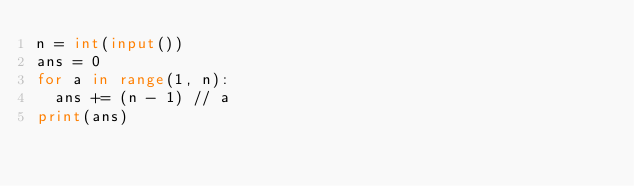<code> <loc_0><loc_0><loc_500><loc_500><_Python_>n = int(input())
ans = 0
for a in range(1, n):
  ans += (n - 1) // a
print(ans)</code> 